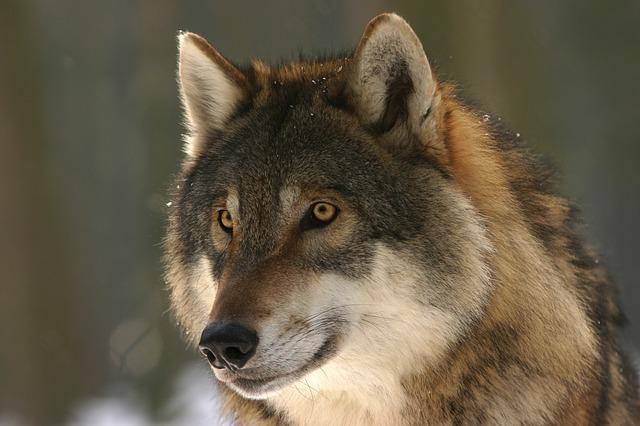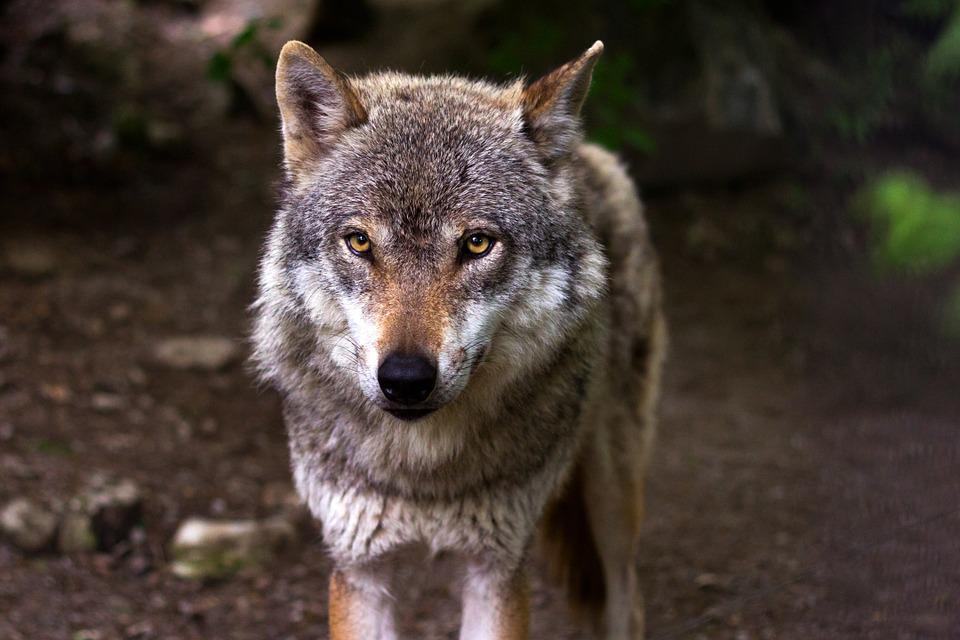The first image is the image on the left, the second image is the image on the right. Examine the images to the left and right. Is the description "there are two wolves standing close together" accurate? Answer yes or no. No. The first image is the image on the left, the second image is the image on the right. Assess this claim about the two images: "One image shows two wolves with their faces side-by-side, and the other image features one forward-looking wolf.". Correct or not? Answer yes or no. No. 